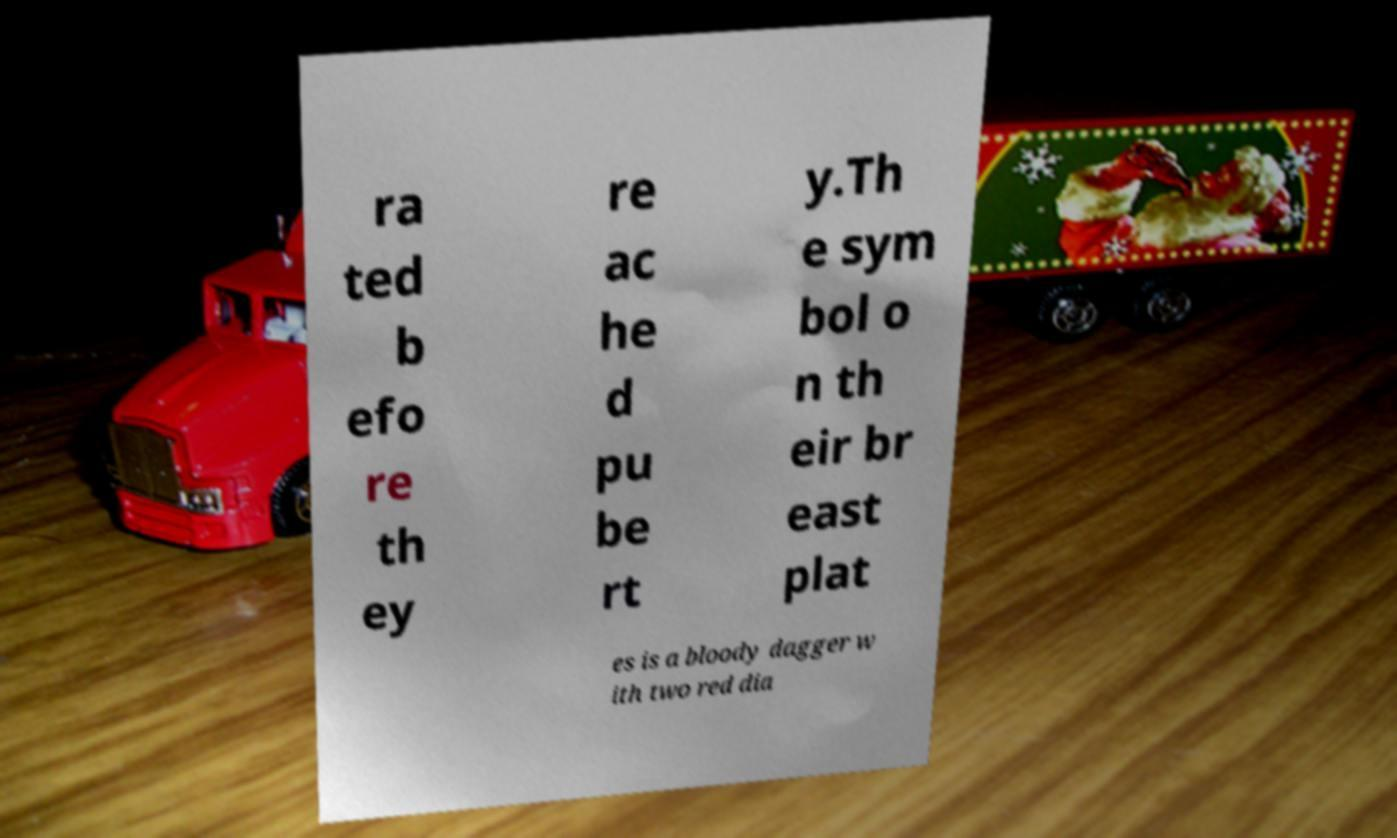Can you read and provide the text displayed in the image?This photo seems to have some interesting text. Can you extract and type it out for me? ra ted b efo re th ey re ac he d pu be rt y.Th e sym bol o n th eir br east plat es is a bloody dagger w ith two red dia 